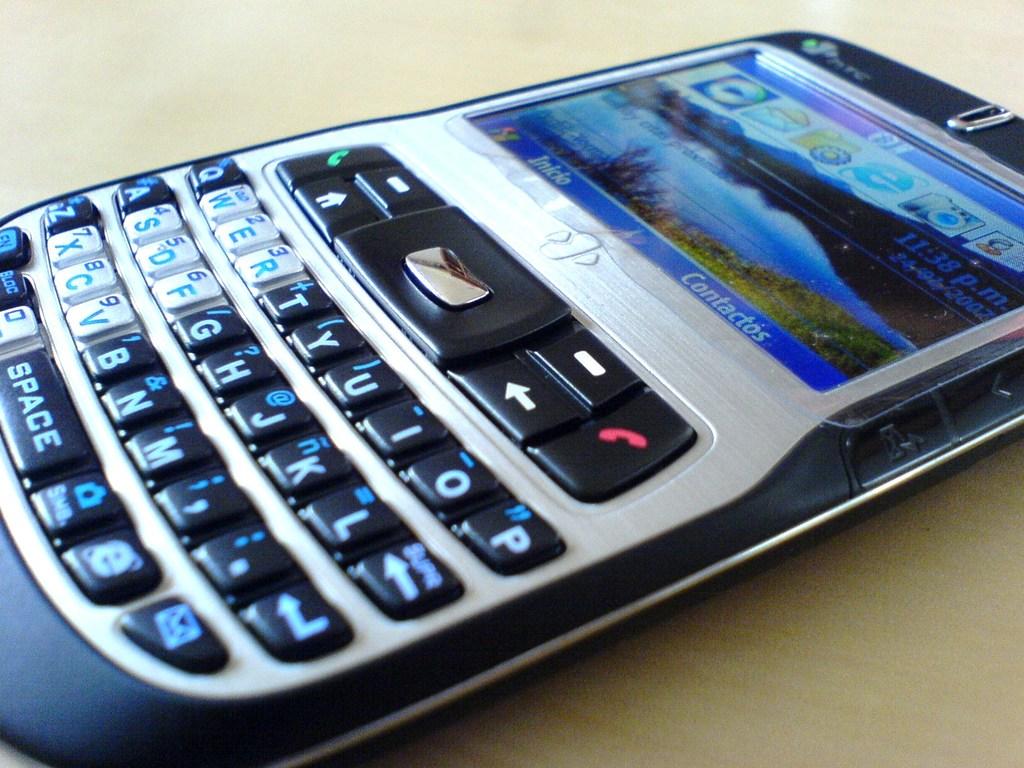What's in the bottom right of the screen?
Offer a terse response. Contactos. What is the large button at the bottom of the phone?
Ensure brevity in your answer.  Space. 